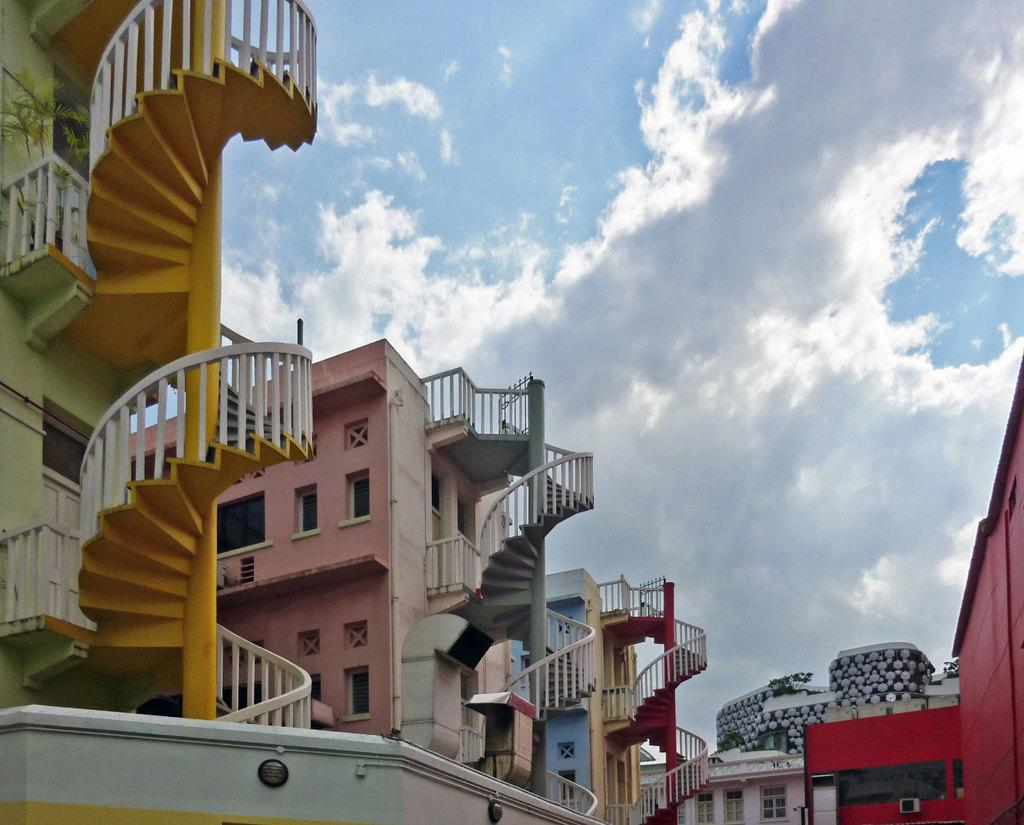What type of structures can be seen in the image? There are many buildings in the image. What architectural feature is present in the image? Concrete stairs are present in the image. What type of barrier can be seen in the image? Fencing is visible in the image. What is visible in the sky in the image? The sky is visible in the image, and clouds are present in it. What type of music is being played by the daughter in the image? There is no daughter or music present in the image. 